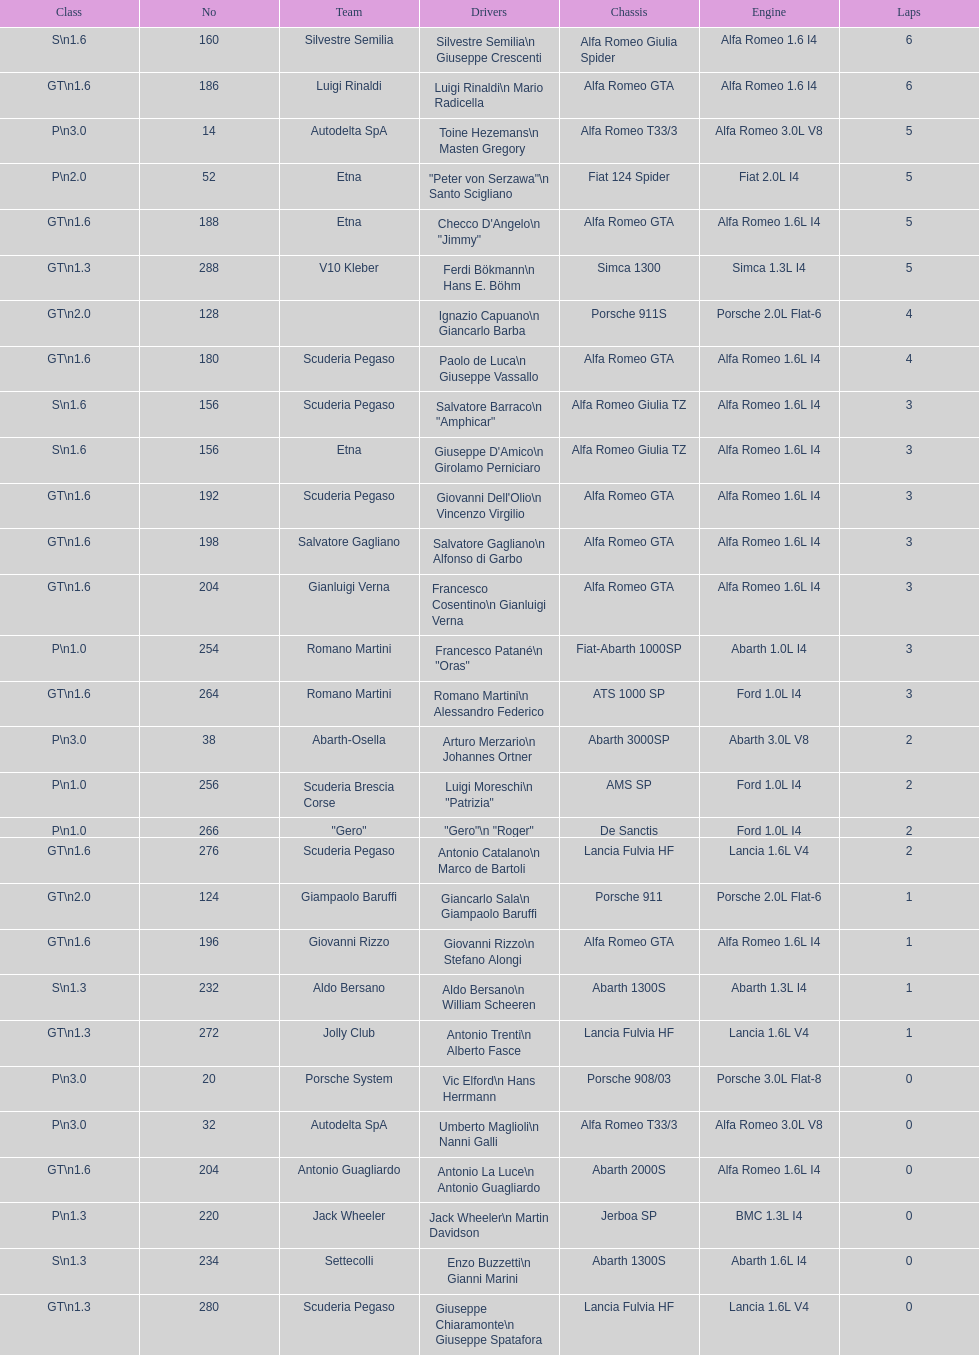Would you be able to parse every entry in this table? {'header': ['Class', 'No', 'Team', 'Drivers', 'Chassis', 'Engine', 'Laps'], 'rows': [['S\\n1.6', '160', 'Silvestre Semilia', 'Silvestre Semilia\\n Giuseppe Crescenti', 'Alfa Romeo Giulia Spider', 'Alfa Romeo 1.6 I4', '6'], ['GT\\n1.6', '186', 'Luigi Rinaldi', 'Luigi Rinaldi\\n Mario Radicella', 'Alfa Romeo GTA', 'Alfa Romeo 1.6 I4', '6'], ['P\\n3.0', '14', 'Autodelta SpA', 'Toine Hezemans\\n Masten Gregory', 'Alfa Romeo T33/3', 'Alfa Romeo 3.0L V8', '5'], ['P\\n2.0', '52', 'Etna', '"Peter von Serzawa"\\n Santo Scigliano', 'Fiat 124 Spider', 'Fiat 2.0L I4', '5'], ['GT\\n1.6', '188', 'Etna', 'Checco D\'Angelo\\n "Jimmy"', 'Alfa Romeo GTA', 'Alfa Romeo 1.6L I4', '5'], ['GT\\n1.3', '288', 'V10 Kleber', 'Ferdi Bökmann\\n Hans E. Böhm', 'Simca 1300', 'Simca 1.3L I4', '5'], ['GT\\n2.0', '128', '', 'Ignazio Capuano\\n Giancarlo Barba', 'Porsche 911S', 'Porsche 2.0L Flat-6', '4'], ['GT\\n1.6', '180', 'Scuderia Pegaso', 'Paolo de Luca\\n Giuseppe Vassallo', 'Alfa Romeo GTA', 'Alfa Romeo 1.6L I4', '4'], ['S\\n1.6', '156', 'Scuderia Pegaso', 'Salvatore Barraco\\n "Amphicar"', 'Alfa Romeo Giulia TZ', 'Alfa Romeo 1.6L I4', '3'], ['S\\n1.6', '156', 'Etna', "Giuseppe D'Amico\\n Girolamo Perniciaro", 'Alfa Romeo Giulia TZ', 'Alfa Romeo 1.6L I4', '3'], ['GT\\n1.6', '192', 'Scuderia Pegaso', "Giovanni Dell'Olio\\n Vincenzo Virgilio", 'Alfa Romeo GTA', 'Alfa Romeo 1.6L I4', '3'], ['GT\\n1.6', '198', 'Salvatore Gagliano', 'Salvatore Gagliano\\n Alfonso di Garbo', 'Alfa Romeo GTA', 'Alfa Romeo 1.6L I4', '3'], ['GT\\n1.6', '204', 'Gianluigi Verna', 'Francesco Cosentino\\n Gianluigi Verna', 'Alfa Romeo GTA', 'Alfa Romeo 1.6L I4', '3'], ['P\\n1.0', '254', 'Romano Martini', 'Francesco Patané\\n "Oras"', 'Fiat-Abarth 1000SP', 'Abarth 1.0L I4', '3'], ['GT\\n1.6', '264', 'Romano Martini', 'Romano Martini\\n Alessandro Federico', 'ATS 1000 SP', 'Ford 1.0L I4', '3'], ['P\\n3.0', '38', 'Abarth-Osella', 'Arturo Merzario\\n Johannes Ortner', 'Abarth 3000SP', 'Abarth 3.0L V8', '2'], ['P\\n1.0', '256', 'Scuderia Brescia Corse', 'Luigi Moreschi\\n "Patrizia"', 'AMS SP', 'Ford 1.0L I4', '2'], ['P\\n1.0', '266', '"Gero"', '"Gero"\\n "Roger"', 'De Sanctis', 'Ford 1.0L I4', '2'], ['GT\\n1.6', '276', 'Scuderia Pegaso', 'Antonio Catalano\\n Marco de Bartoli', 'Lancia Fulvia HF', 'Lancia 1.6L V4', '2'], ['GT\\n2.0', '124', 'Giampaolo Baruffi', 'Giancarlo Sala\\n Giampaolo Baruffi', 'Porsche 911', 'Porsche 2.0L Flat-6', '1'], ['GT\\n1.6', '196', 'Giovanni Rizzo', 'Giovanni Rizzo\\n Stefano Alongi', 'Alfa Romeo GTA', 'Alfa Romeo 1.6L I4', '1'], ['S\\n1.3', '232', 'Aldo Bersano', 'Aldo Bersano\\n William Scheeren', 'Abarth 1300S', 'Abarth 1.3L I4', '1'], ['GT\\n1.3', '272', 'Jolly Club', 'Antonio Trenti\\n Alberto Fasce', 'Lancia Fulvia HF', 'Lancia 1.6L V4', '1'], ['P\\n3.0', '20', 'Porsche System', 'Vic Elford\\n Hans Herrmann', 'Porsche 908/03', 'Porsche 3.0L Flat-8', '0'], ['P\\n3.0', '32', 'Autodelta SpA', 'Umberto Maglioli\\n Nanni Galli', 'Alfa Romeo T33/3', 'Alfa Romeo 3.0L V8', '0'], ['GT\\n1.6', '204', 'Antonio Guagliardo', 'Antonio La Luce\\n Antonio Guagliardo', 'Abarth 2000S', 'Alfa Romeo 1.6L I4', '0'], ['P\\n1.3', '220', 'Jack Wheeler', 'Jack Wheeler\\n Martin Davidson', 'Jerboa SP', 'BMC 1.3L I4', '0'], ['S\\n1.3', '234', 'Settecolli', 'Enzo Buzzetti\\n Gianni Marini', 'Abarth 1300S', 'Abarth 1.6L I4', '0'], ['GT\\n1.3', '280', 'Scuderia Pegaso', 'Giuseppe Chiaramonte\\n Giuseppe Spatafora', 'Lancia Fulvia HF', 'Lancia 1.6L V4', '0']]} If "jimmy" is his nickname, what is his actual full name? Checco D'Angelo. 